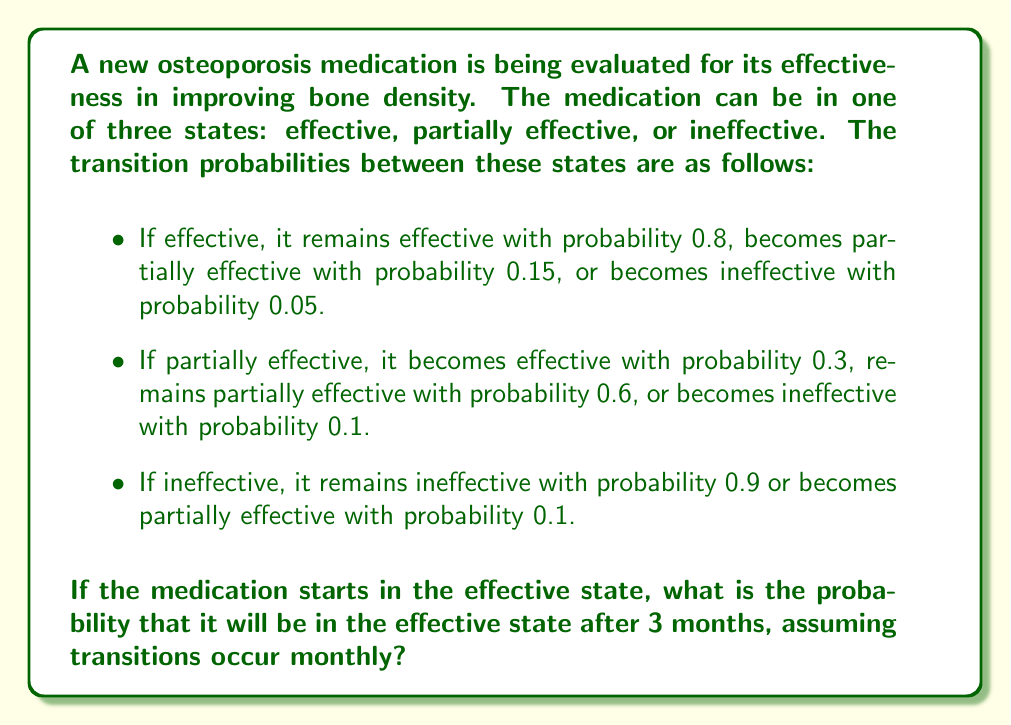Can you answer this question? Let's approach this step-by-step using Markov chains:

1) First, we need to define our transition matrix P:

   $$P = \begin{bmatrix} 
   0.8 & 0.15 & 0.05 \\
   0.3 & 0.6 & 0.1 \\
   0 & 0.1 & 0.9
   \end{bmatrix}$$

   where the states are ordered as [Effective, Partially Effective, Ineffective].

2) We want to find the state after 3 transitions, so we need to compute $P^3$:

   $$P^3 = P \times P \times P$$

3) We can calculate this using matrix multiplication:

   $$P^2 = \begin{bmatrix} 
   0.69 & 0.24 & 0.07 \\
   0.48 & 0.44 & 0.08 \\
   0.03 & 0.16 & 0.81
   \end{bmatrix}$$

   $$P^3 = \begin{bmatrix} 
   0.6069 & 0.2895 & 0.1036 \\
   0.5301 & 0.3657 & 0.1042 \\
   0.0573 & 0.2089 & 0.7338
   \end{bmatrix}$$

4) The initial state vector is $[1, 0, 0]$ since the medication starts in the effective state.

5) To find the probability of being in the effective state after 3 months, we look at the first entry of the first row of $P^3$, which is approximately 0.6069.

Therefore, the probability that the medication will be in the effective state after 3 months, given that it starts in the effective state, is approximately 0.6069 or 60.69%.
Answer: 0.6069 